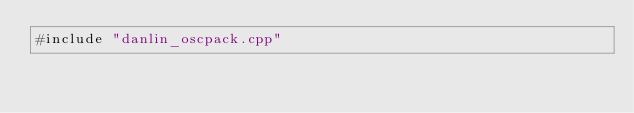Convert code to text. <code><loc_0><loc_0><loc_500><loc_500><_ObjectiveC_>#include "danlin_oscpack.cpp"
</code> 